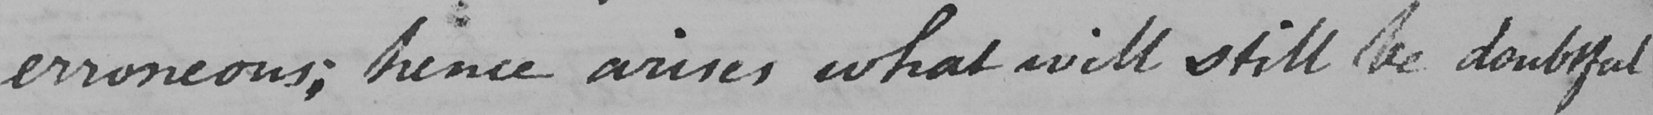Can you read and transcribe this handwriting? erroneous ; hence arises what will still be doubtful 